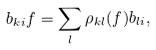Convert formula to latex. <formula><loc_0><loc_0><loc_500><loc_500>b _ { k i } f = \sum _ { l } \rho _ { k l } ( f ) b _ { l i } ,</formula> 